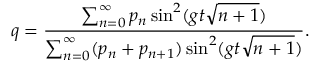Convert formula to latex. <formula><loc_0><loc_0><loc_500><loc_500>q = \frac { \sum _ { n = 0 } ^ { \infty } p _ { n } \sin ^ { 2 } ( g t \sqrt { n + 1 } ) } { \sum _ { n = 0 } ^ { \infty } ( p _ { n } + p _ { n + 1 } ) \sin ^ { 2 } ( g t \sqrt { n + 1 } ) } .</formula> 